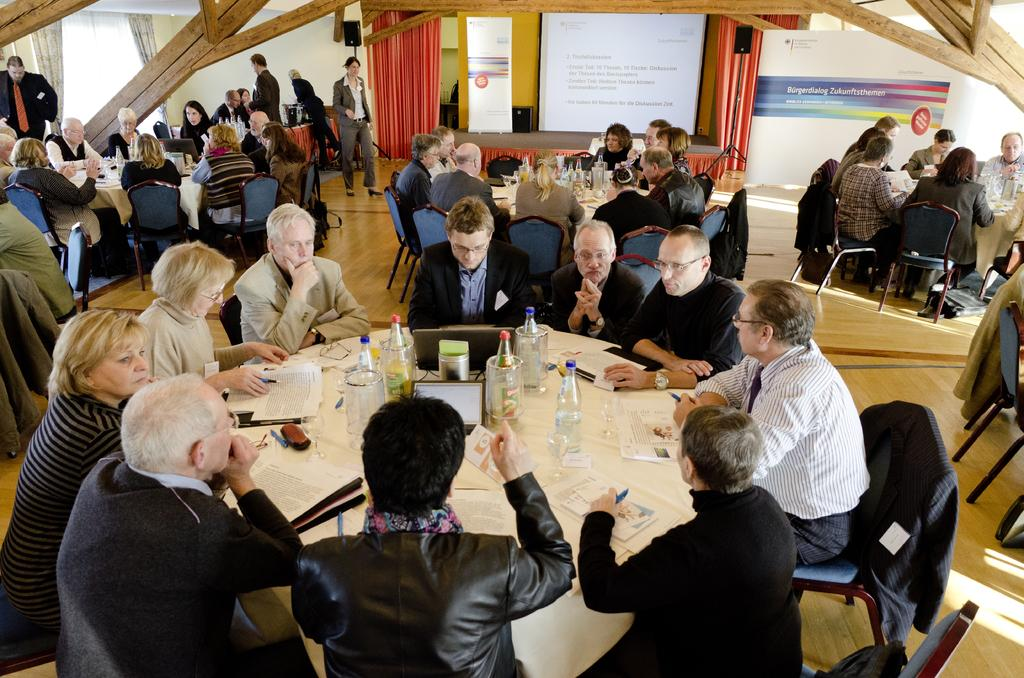What are the people in the image doing? There is a group of people sitting on chairs in the image. What is in front of the chairs? There is a table in front of the chairs. What can be seen on the table? Laptops and bottles are present on the table, along with other objects. What is the large sign in the image called? There is a hoarding in the image. What type of scarf is draped over the branch in the image? There is no scarf or branch present in the image. How many times do the people shake hands in the image? There is no indication of people shaking hands in the image. 